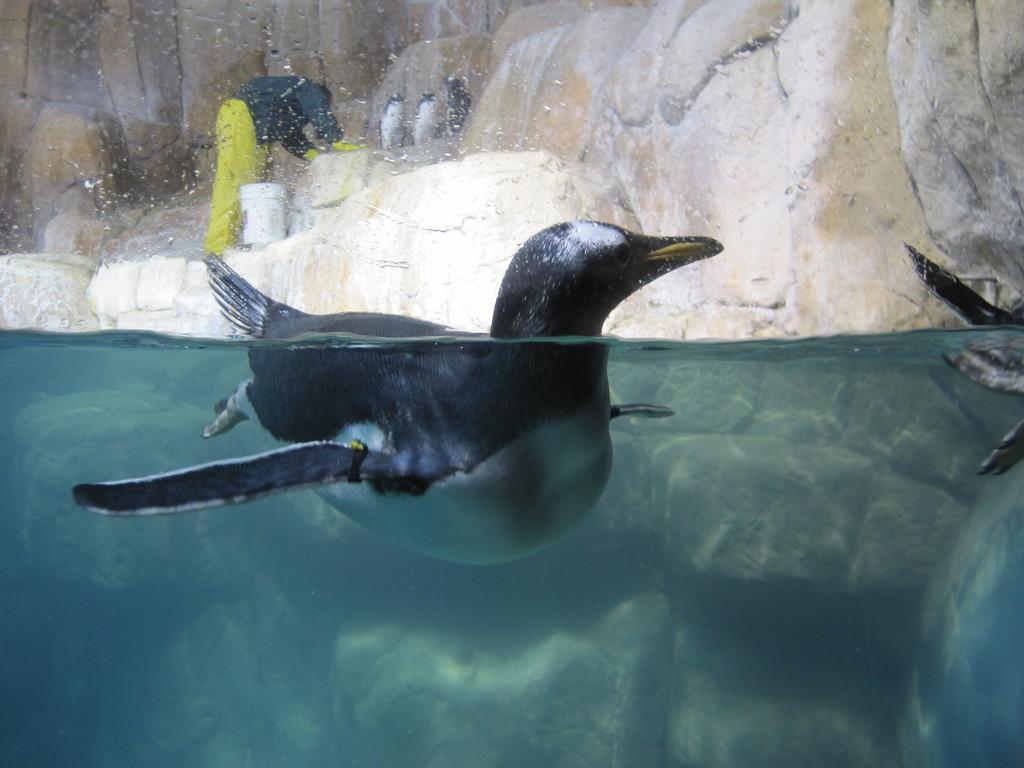What is the aquatic animal doing in the image? The aquatic animal is swimming in the water. What is the person doing in the image? The person is standing on a rock. What object is beside the person? There is a bucket beside the person. What else can be seen on the rock? There are animals on the rock. Can you describe the animal on the right side of the image in the water? There is an animal on the right side of the image in the water. How many frogs are sitting on the edge of the rock in the image? There is no mention of frogs or an edge in the provided facts, so we cannot answer this question. Are there any ducks visible in the image? There is no mention of ducks in the provided facts, so we cannot answer this question. 